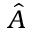Convert formula to latex. <formula><loc_0><loc_0><loc_500><loc_500>\hat { A }</formula> 